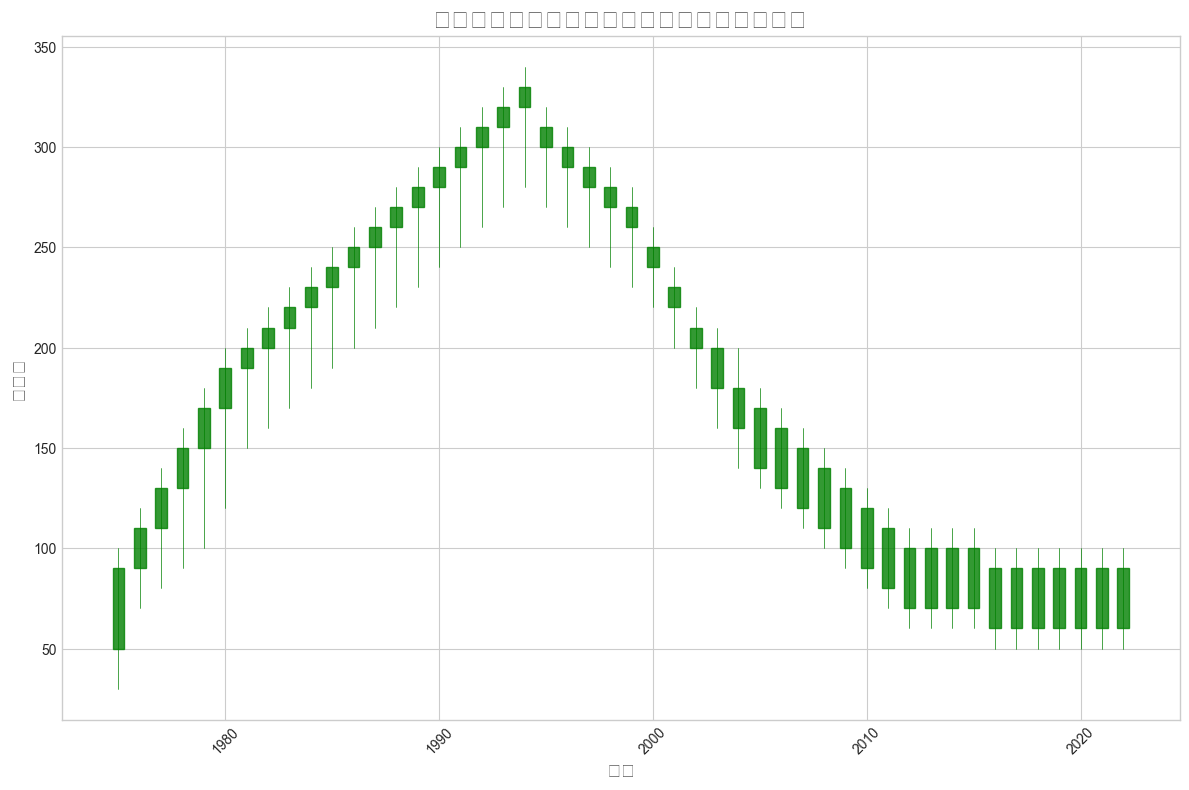高峰时期(即收视率最高的时期)和低谷时期(收视率最低的时期)分别是什么时候？ 根据图表，最高的收视率出现在1984年和1985年，最低的收视率出现在2016年到2022年之间
Answer: 1984年和1985年; 2016年到2022年 电视剧收视率在哪个年份之间下降幅度最大？ 图表显示从1994年到1995年是收视率下降幅度最大的一年，收视率从330下降到310
Answer: 1994年到1995年 在什么年份香港电视剧收视率的波动最大？ 找出影线最长的年份，该年份的开盘价和收盘价与最高价和最低价之间的差距最大。1980年，收视率波动最大，开盘价170，最高价200，最低价120，收盘价190
Answer: 1980年 电视剧收视率在1990年到2000年之间的趋势是怎样的？ 从1990年到1995年是下降趋势，1995年到2000年继续下降
Answer: 连续下降 哪个年份的收视率开盘价和收盘价相差最大？ 比较图表中每年的开盘价和收盘价的差值，1975年开盘价50，收盘价90，相差最大，差值为40
Answer: 1975年 1960年到1980年香港电视剧收视率的整体趋势如何？ 从1960年到1980年，收视率趋势是上升的
Answer: 上升 在1983年和1993年间，收视率首次跌至200以下，是在哪个年份？ 1983年收视率首次达到200，1994年收视率跌至200以下，再次达到1995年
Answer: 1995年 每个十年中收视率创新高的年份有哪些？ 1970年代的1979年, 1980年代的1989年, 1990年代的1993年, 2000年代的2009年, 2010年代的2011年
Answer: 1979年, 1989年, 1993年, 2009年, 2011年 收视率在哪一年首次突破230？ 查看图表确认收视率首次超过230的年份是1985年
Answer: 1985年 哪一年收视率高于270但收盘价却低于270？ 搜索图表中符合条件的年份，是1994年和1995年
Answer: 1995年 